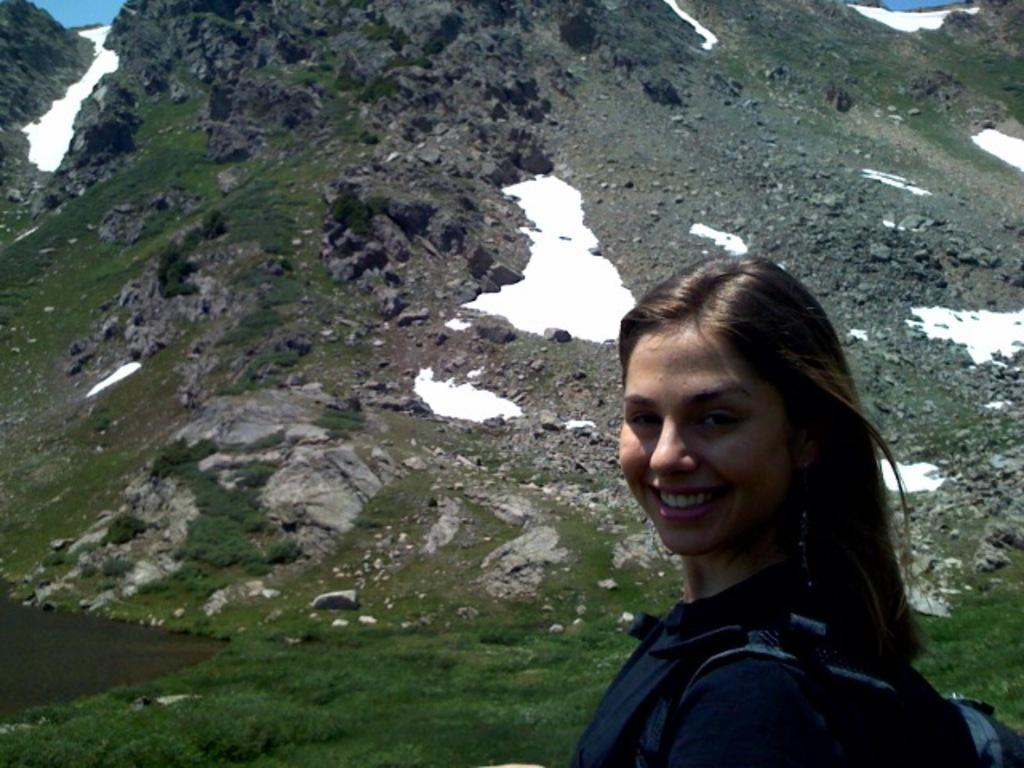Who is present in the image? There is a woman in the image. What is the woman carrying? The woman is carrying a bag. What type of terrain is visible in the image? There is grass on the rock hill and snow on some parts of the rock hills in the image. What type of stitch is used to sew the train in the image? There is no train present in the image, so it is not possible to determine the type of stitch used for sewing. 